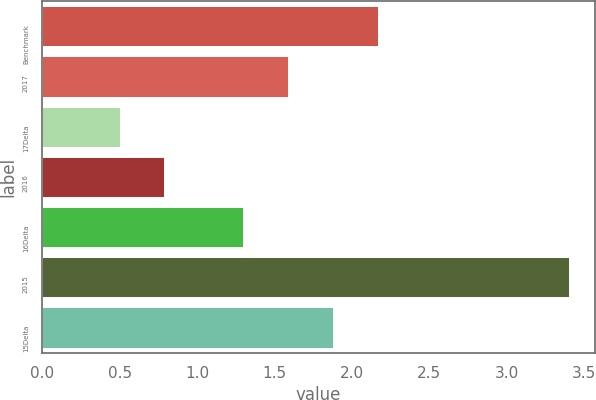Convert chart. <chart><loc_0><loc_0><loc_500><loc_500><bar_chart><fcel>Benchmark<fcel>2017<fcel>17Delta<fcel>2016<fcel>16Delta<fcel>2015<fcel>15Delta<nl><fcel>2.17<fcel>1.59<fcel>0.5<fcel>0.79<fcel>1.3<fcel>3.4<fcel>1.88<nl></chart> 